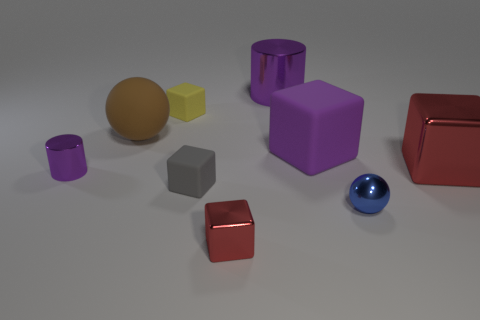The matte block that is the same color as the large metal cylinder is what size?
Ensure brevity in your answer.  Large. Is the material of the ball in front of the big red shiny object the same as the ball left of the yellow matte thing?
Offer a terse response. No. What is the material of the big cylinder that is the same color as the tiny cylinder?
Your answer should be very brief. Metal. How many small brown objects are the same shape as the small gray object?
Your answer should be very brief. 0. Is the number of objects on the right side of the big purple matte object greater than the number of purple cylinders?
Your response must be concise. No. What shape is the big metal object that is behind the large shiny object that is right of the purple metallic cylinder that is on the right side of the tiny red metal block?
Your answer should be very brief. Cylinder. There is a purple metal thing to the right of the tiny yellow thing; does it have the same shape as the matte object that is right of the small red metal object?
Keep it short and to the point. No. How many cubes are large purple matte things or blue objects?
Your answer should be compact. 1. Is the material of the big brown ball the same as the purple cube?
Give a very brief answer. Yes. What number of other objects are the same color as the large shiny cylinder?
Provide a succinct answer. 2. 